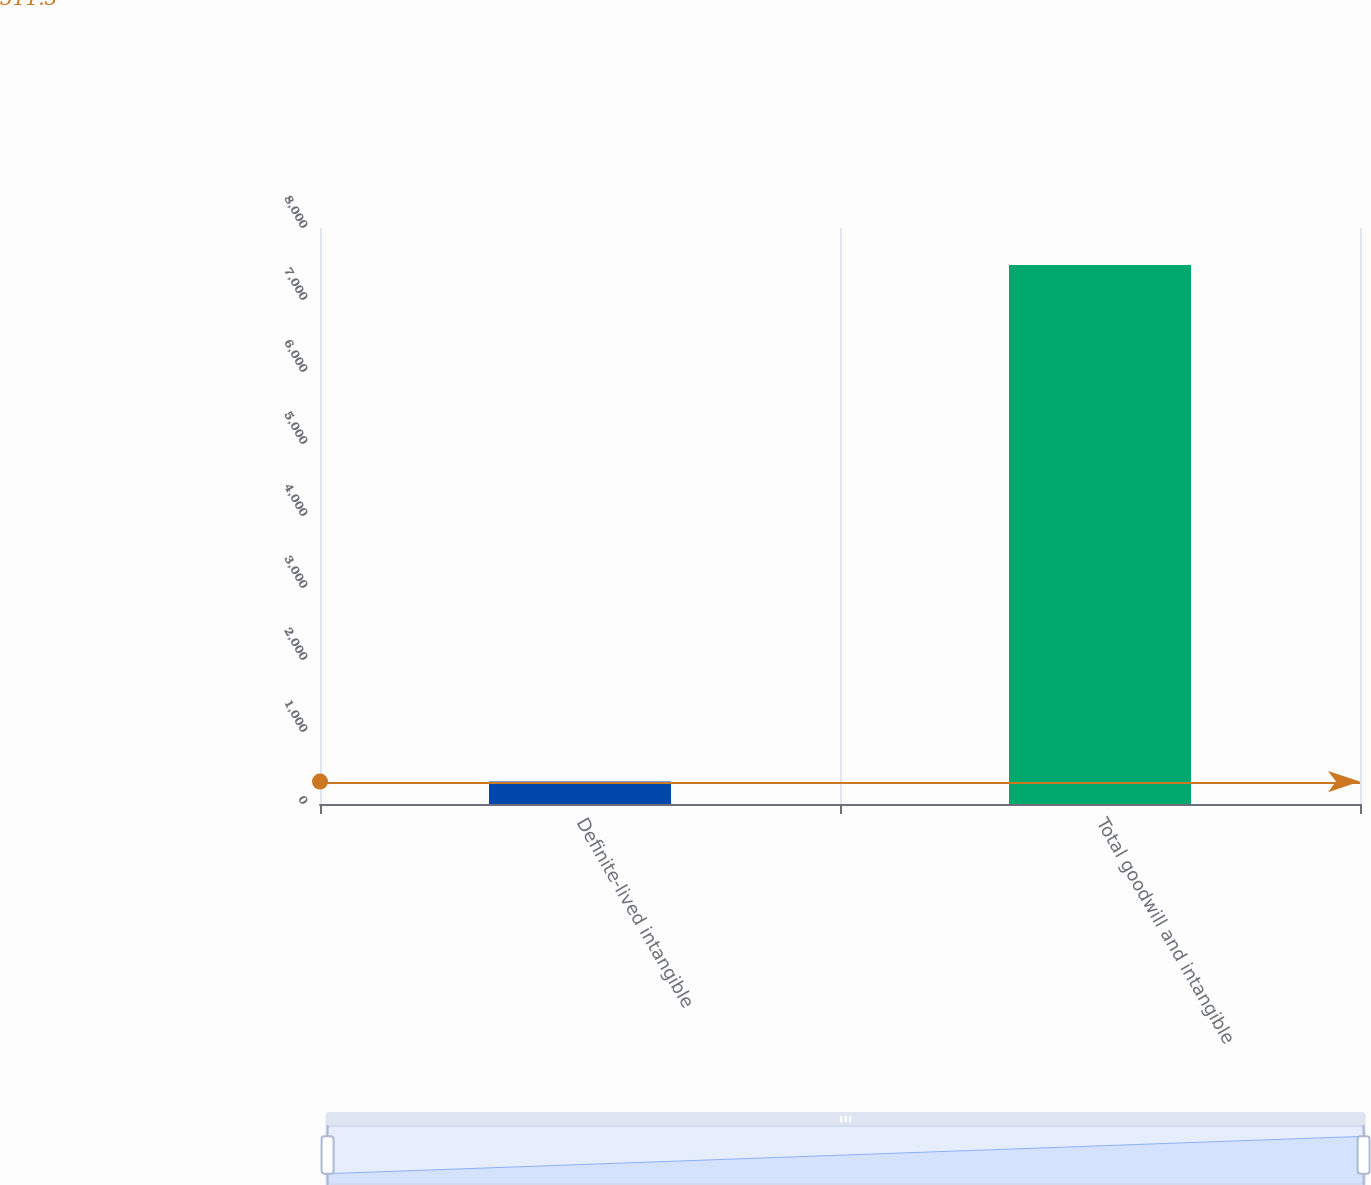Convert chart to OTSL. <chart><loc_0><loc_0><loc_500><loc_500><bar_chart><fcel>Definite-lived intangible<fcel>Total goodwill and intangible<nl><fcel>311.3<fcel>7486.1<nl></chart> 